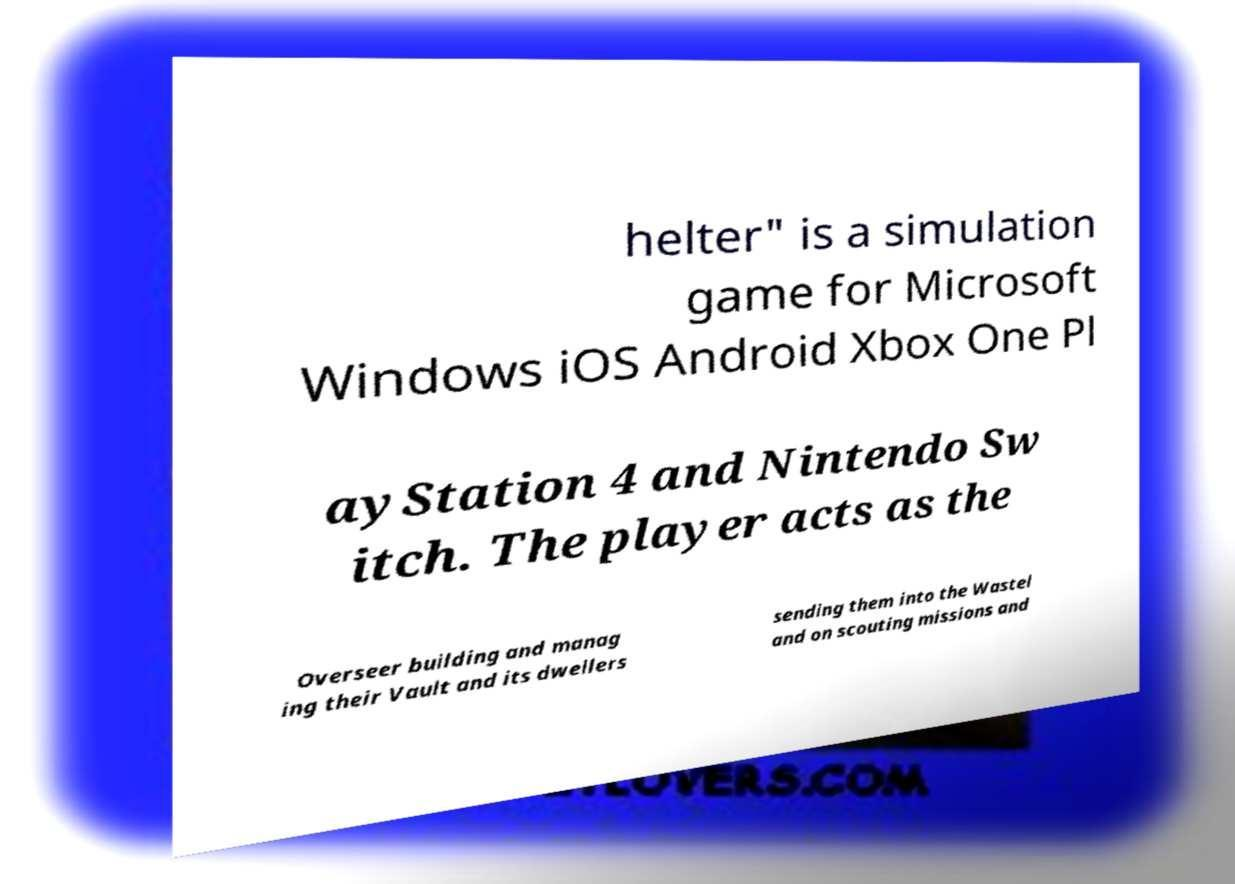I need the written content from this picture converted into text. Can you do that? helter" is a simulation game for Microsoft Windows iOS Android Xbox One Pl ayStation 4 and Nintendo Sw itch. The player acts as the Overseer building and manag ing their Vault and its dwellers sending them into the Wastel and on scouting missions and 